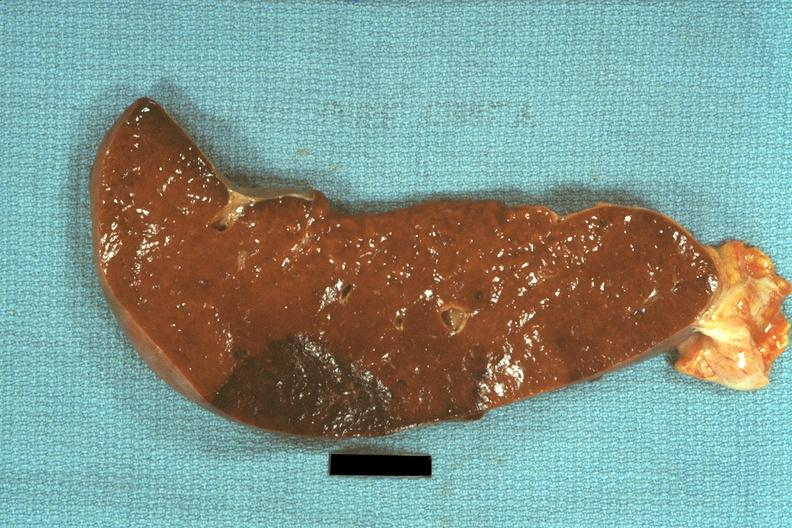what is present?
Answer the question using a single word or phrase. Hematologic 